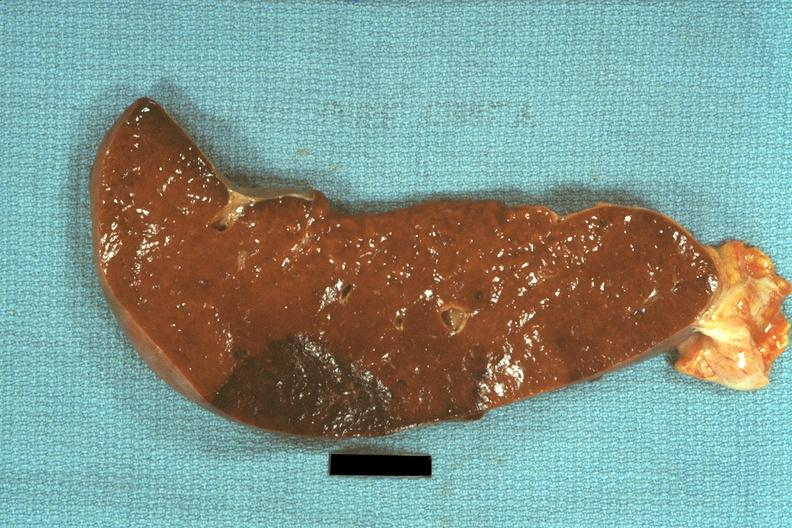what is present?
Answer the question using a single word or phrase. Hematologic 